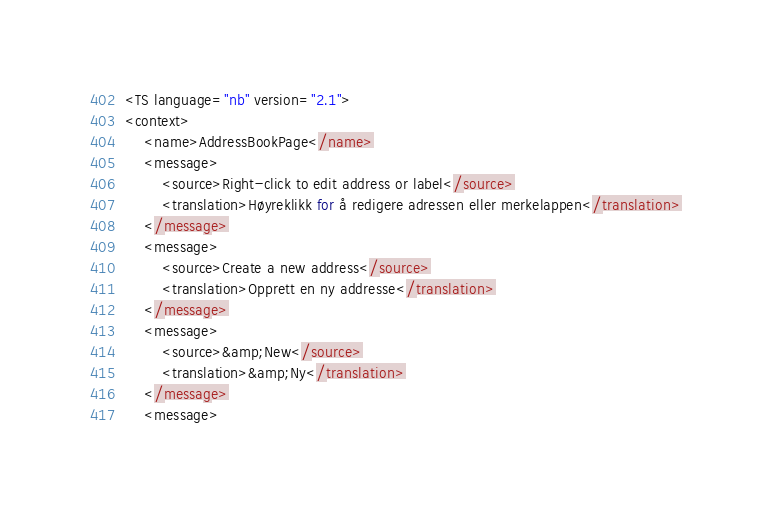Convert code to text. <code><loc_0><loc_0><loc_500><loc_500><_TypeScript_><TS language="nb" version="2.1">
<context>
    <name>AddressBookPage</name>
    <message>
        <source>Right-click to edit address or label</source>
        <translation>Høyreklikk for å redigere adressen eller merkelappen</translation>
    </message>
    <message>
        <source>Create a new address</source>
        <translation>Opprett en ny addresse</translation>
    </message>
    <message>
        <source>&amp;New</source>
        <translation>&amp;Ny</translation>
    </message>
    <message></code> 